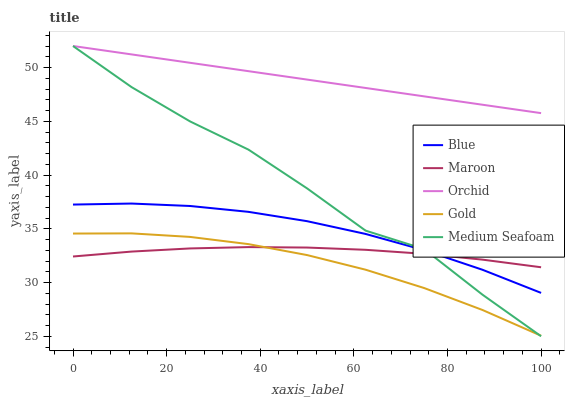Does Gold have the minimum area under the curve?
Answer yes or no. Yes. Does Orchid have the maximum area under the curve?
Answer yes or no. Yes. Does Medium Seafoam have the minimum area under the curve?
Answer yes or no. No. Does Medium Seafoam have the maximum area under the curve?
Answer yes or no. No. Is Orchid the smoothest?
Answer yes or no. Yes. Is Medium Seafoam the roughest?
Answer yes or no. Yes. Is Gold the smoothest?
Answer yes or no. No. Is Gold the roughest?
Answer yes or no. No. Does Medium Seafoam have the lowest value?
Answer yes or no. Yes. Does Gold have the lowest value?
Answer yes or no. No. Does Orchid have the highest value?
Answer yes or no. Yes. Does Gold have the highest value?
Answer yes or no. No. Is Gold less than Blue?
Answer yes or no. Yes. Is Orchid greater than Gold?
Answer yes or no. Yes. Does Maroon intersect Gold?
Answer yes or no. Yes. Is Maroon less than Gold?
Answer yes or no. No. Is Maroon greater than Gold?
Answer yes or no. No. Does Gold intersect Blue?
Answer yes or no. No. 